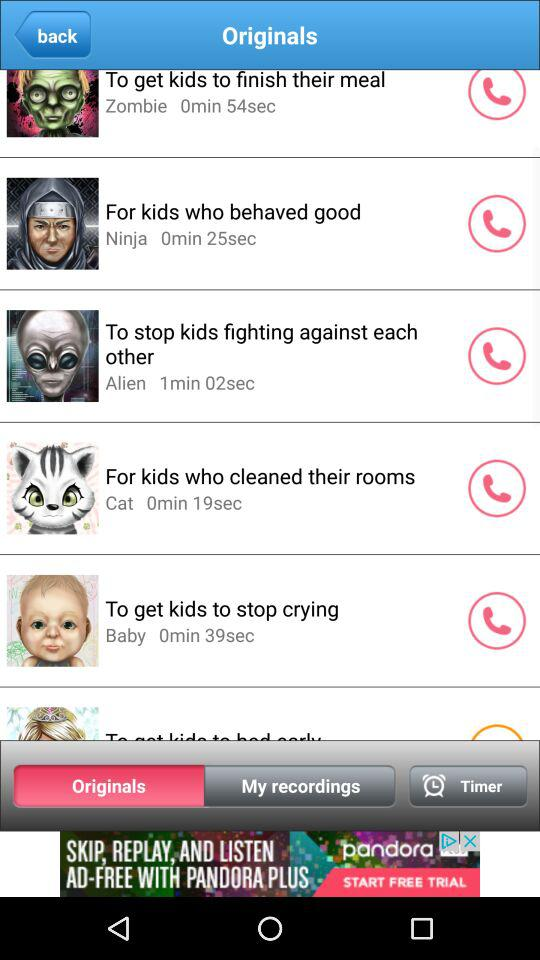What is the duration of "To get kids to stop crying"? The duration is 39 seconds. 